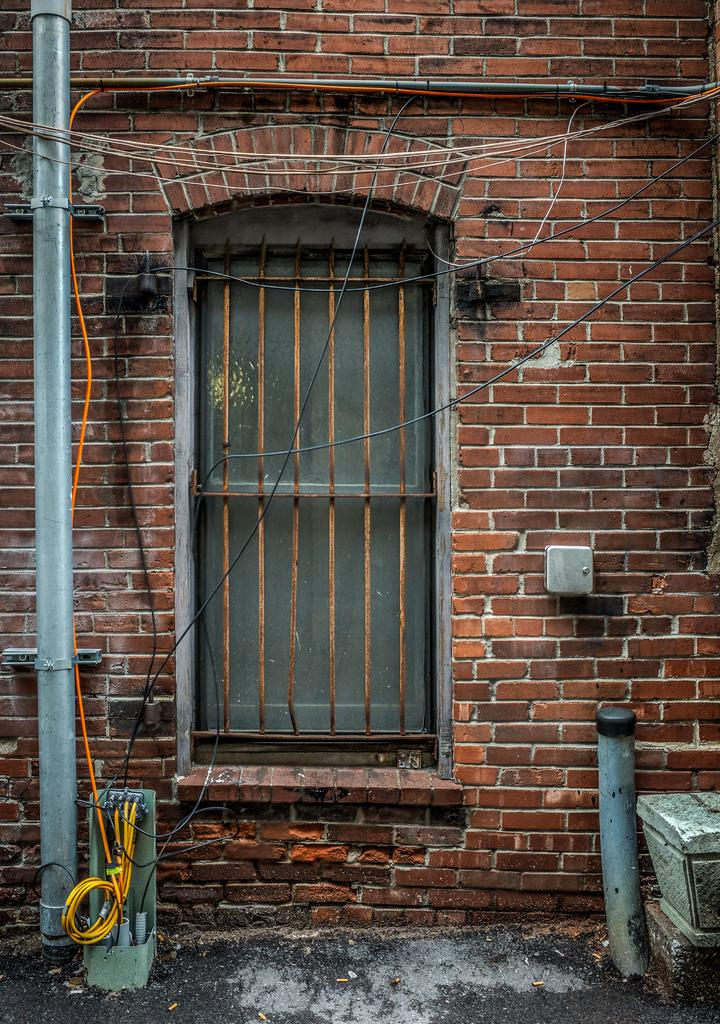What type of structure is visible in the image? There is a brick wall in the image. What architectural feature can be seen in the wall? There is a window in the image. What is located on the left side of the image? A pole and wires are present on the left side of the image. What is on the right side of the image? There is a circular object and a white color object on the right side of the image. What type of plastic material can be seen in the image? There is no plastic material present in the image. What taste can be experienced from the brick wall in the image? The brick wall does not have a taste, as it is a non-edible object. 